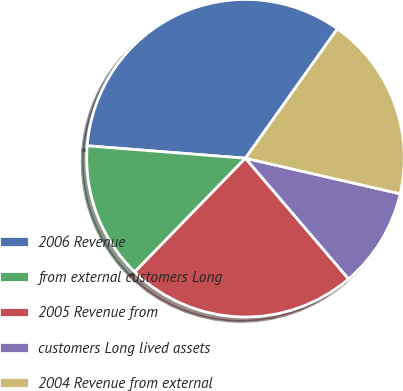<chart> <loc_0><loc_0><loc_500><loc_500><pie_chart><fcel>2006 Revenue<fcel>from external customers Long<fcel>2005 Revenue from<fcel>customers Long lived assets<fcel>2004 Revenue from external<nl><fcel>33.58%<fcel>13.96%<fcel>23.54%<fcel>10.15%<fcel>18.77%<nl></chart> 